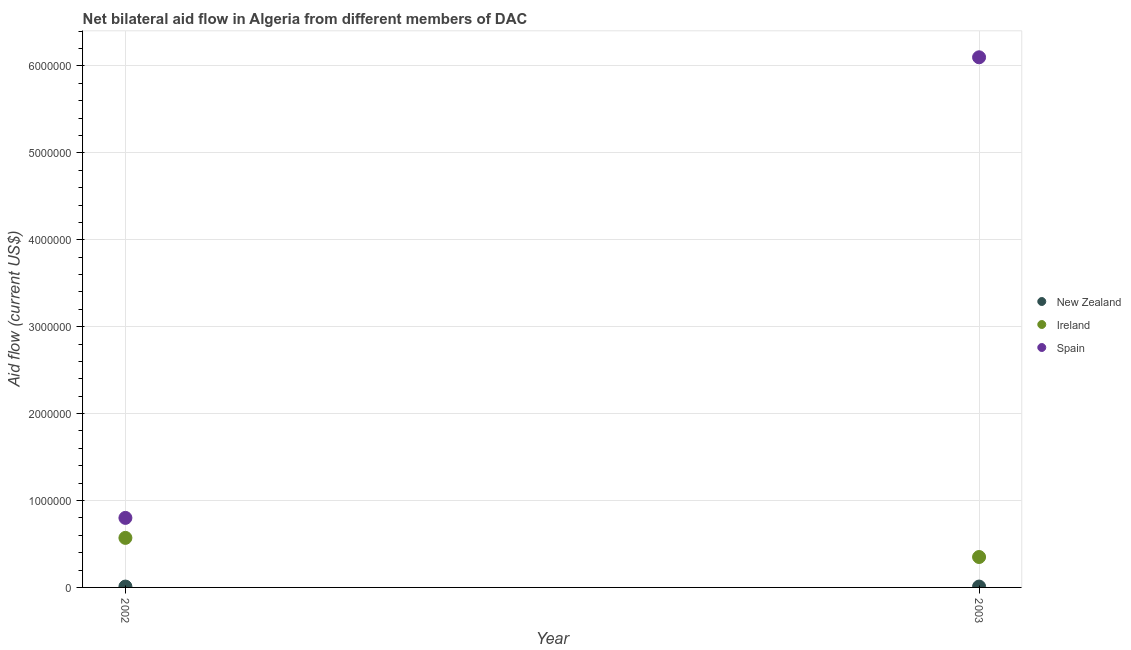What is the amount of aid provided by spain in 2002?
Your answer should be compact. 8.00e+05. Across all years, what is the maximum amount of aid provided by spain?
Your answer should be very brief. 6.10e+06. Across all years, what is the minimum amount of aid provided by ireland?
Make the answer very short. 3.50e+05. What is the total amount of aid provided by new zealand in the graph?
Your answer should be very brief. 2.00e+04. What is the difference between the amount of aid provided by spain in 2002 and that in 2003?
Provide a short and direct response. -5.30e+06. What is the difference between the amount of aid provided by spain in 2003 and the amount of aid provided by ireland in 2002?
Offer a very short reply. 5.53e+06. What is the average amount of aid provided by spain per year?
Your answer should be compact. 3.45e+06. In the year 2002, what is the difference between the amount of aid provided by spain and amount of aid provided by new zealand?
Give a very brief answer. 7.90e+05. In how many years, is the amount of aid provided by spain greater than 5200000 US$?
Make the answer very short. 1. What is the ratio of the amount of aid provided by spain in 2002 to that in 2003?
Offer a terse response. 0.13. In how many years, is the amount of aid provided by spain greater than the average amount of aid provided by spain taken over all years?
Your response must be concise. 1. Is it the case that in every year, the sum of the amount of aid provided by new zealand and amount of aid provided by ireland is greater than the amount of aid provided by spain?
Keep it short and to the point. No. Does the amount of aid provided by spain monotonically increase over the years?
Keep it short and to the point. Yes. How many dotlines are there?
Your answer should be very brief. 3. What is the difference between two consecutive major ticks on the Y-axis?
Your response must be concise. 1.00e+06. Are the values on the major ticks of Y-axis written in scientific E-notation?
Your response must be concise. No. How are the legend labels stacked?
Offer a terse response. Vertical. What is the title of the graph?
Provide a short and direct response. Net bilateral aid flow in Algeria from different members of DAC. What is the Aid flow (current US$) of Ireland in 2002?
Give a very brief answer. 5.70e+05. What is the Aid flow (current US$) in New Zealand in 2003?
Your response must be concise. 10000. What is the Aid flow (current US$) in Ireland in 2003?
Your answer should be compact. 3.50e+05. What is the Aid flow (current US$) in Spain in 2003?
Offer a very short reply. 6.10e+06. Across all years, what is the maximum Aid flow (current US$) of New Zealand?
Make the answer very short. 10000. Across all years, what is the maximum Aid flow (current US$) of Ireland?
Your response must be concise. 5.70e+05. Across all years, what is the maximum Aid flow (current US$) in Spain?
Provide a short and direct response. 6.10e+06. Across all years, what is the minimum Aid flow (current US$) in Ireland?
Keep it short and to the point. 3.50e+05. What is the total Aid flow (current US$) in New Zealand in the graph?
Provide a succinct answer. 2.00e+04. What is the total Aid flow (current US$) in Ireland in the graph?
Your answer should be very brief. 9.20e+05. What is the total Aid flow (current US$) in Spain in the graph?
Ensure brevity in your answer.  6.90e+06. What is the difference between the Aid flow (current US$) in Spain in 2002 and that in 2003?
Provide a succinct answer. -5.30e+06. What is the difference between the Aid flow (current US$) in New Zealand in 2002 and the Aid flow (current US$) in Spain in 2003?
Keep it short and to the point. -6.09e+06. What is the difference between the Aid flow (current US$) of Ireland in 2002 and the Aid flow (current US$) of Spain in 2003?
Make the answer very short. -5.53e+06. What is the average Aid flow (current US$) in Ireland per year?
Make the answer very short. 4.60e+05. What is the average Aid flow (current US$) of Spain per year?
Your response must be concise. 3.45e+06. In the year 2002, what is the difference between the Aid flow (current US$) in New Zealand and Aid flow (current US$) in Ireland?
Provide a succinct answer. -5.60e+05. In the year 2002, what is the difference between the Aid flow (current US$) in New Zealand and Aid flow (current US$) in Spain?
Ensure brevity in your answer.  -7.90e+05. In the year 2003, what is the difference between the Aid flow (current US$) of New Zealand and Aid flow (current US$) of Spain?
Make the answer very short. -6.09e+06. In the year 2003, what is the difference between the Aid flow (current US$) in Ireland and Aid flow (current US$) in Spain?
Your answer should be very brief. -5.75e+06. What is the ratio of the Aid flow (current US$) of Ireland in 2002 to that in 2003?
Your answer should be very brief. 1.63. What is the ratio of the Aid flow (current US$) of Spain in 2002 to that in 2003?
Provide a short and direct response. 0.13. What is the difference between the highest and the second highest Aid flow (current US$) of Ireland?
Make the answer very short. 2.20e+05. What is the difference between the highest and the second highest Aid flow (current US$) in Spain?
Provide a short and direct response. 5.30e+06. What is the difference between the highest and the lowest Aid flow (current US$) in Ireland?
Your response must be concise. 2.20e+05. What is the difference between the highest and the lowest Aid flow (current US$) of Spain?
Offer a very short reply. 5.30e+06. 